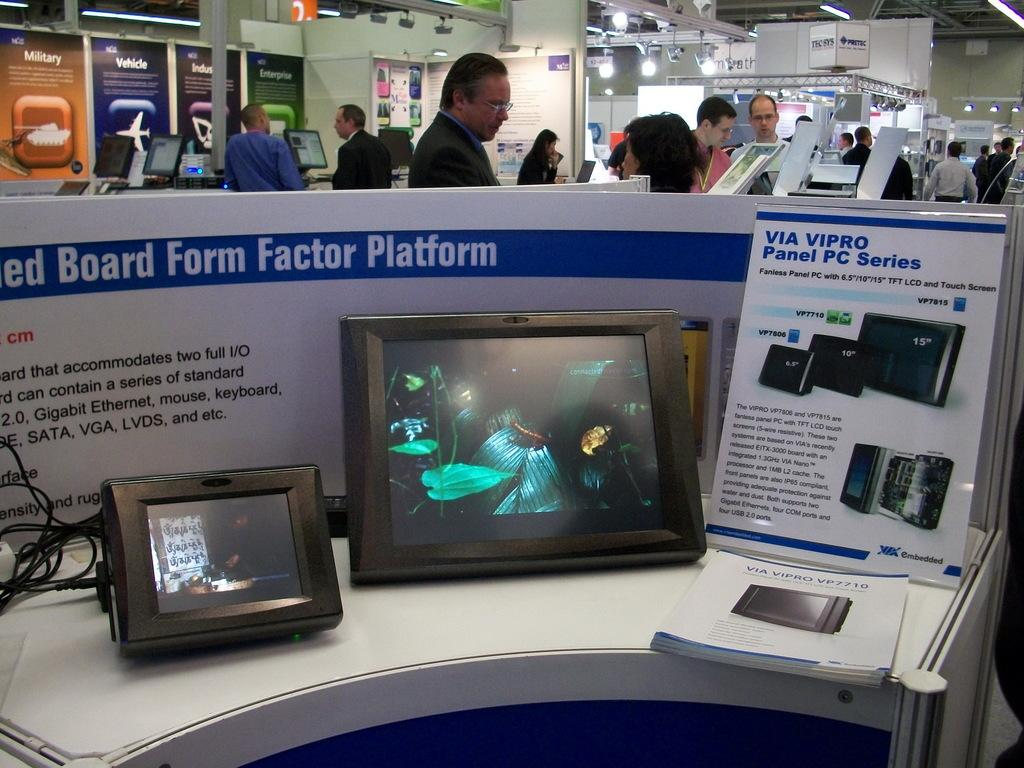<image>
Share a concise interpretation of the image provided. Via Vipro panel pc series inside a store with people included 